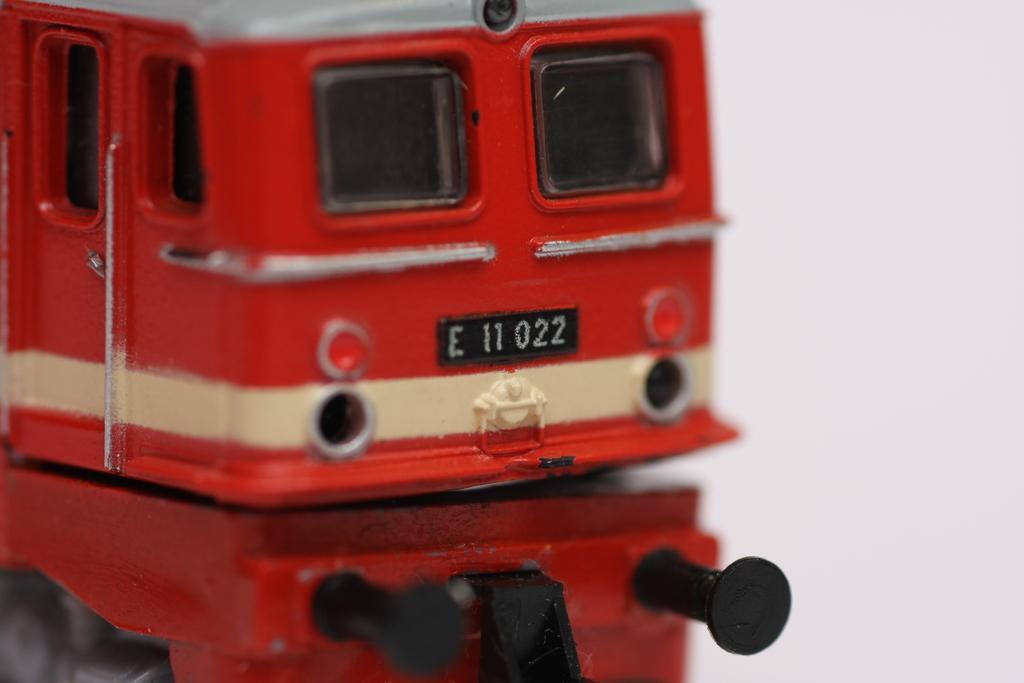Can you describe this image briefly? In this image we can see there is a toy vehicle and there is a reflection of the toy. 